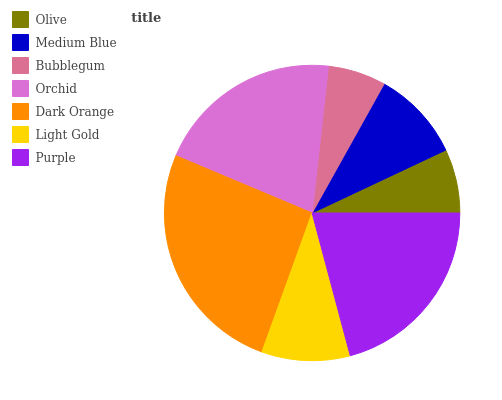Is Bubblegum the minimum?
Answer yes or no. Yes. Is Dark Orange the maximum?
Answer yes or no. Yes. Is Medium Blue the minimum?
Answer yes or no. No. Is Medium Blue the maximum?
Answer yes or no. No. Is Medium Blue greater than Olive?
Answer yes or no. Yes. Is Olive less than Medium Blue?
Answer yes or no. Yes. Is Olive greater than Medium Blue?
Answer yes or no. No. Is Medium Blue less than Olive?
Answer yes or no. No. Is Medium Blue the high median?
Answer yes or no. Yes. Is Medium Blue the low median?
Answer yes or no. Yes. Is Dark Orange the high median?
Answer yes or no. No. Is Bubblegum the low median?
Answer yes or no. No. 